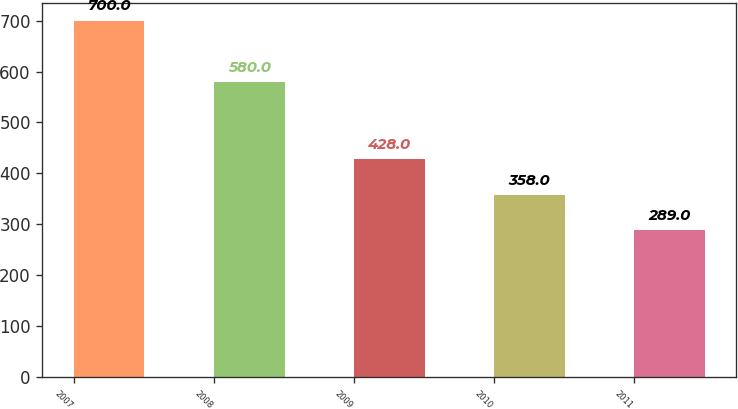Convert chart to OTSL. <chart><loc_0><loc_0><loc_500><loc_500><bar_chart><fcel>2007<fcel>2008<fcel>2009<fcel>2010<fcel>2011<nl><fcel>700<fcel>580<fcel>428<fcel>358<fcel>289<nl></chart> 